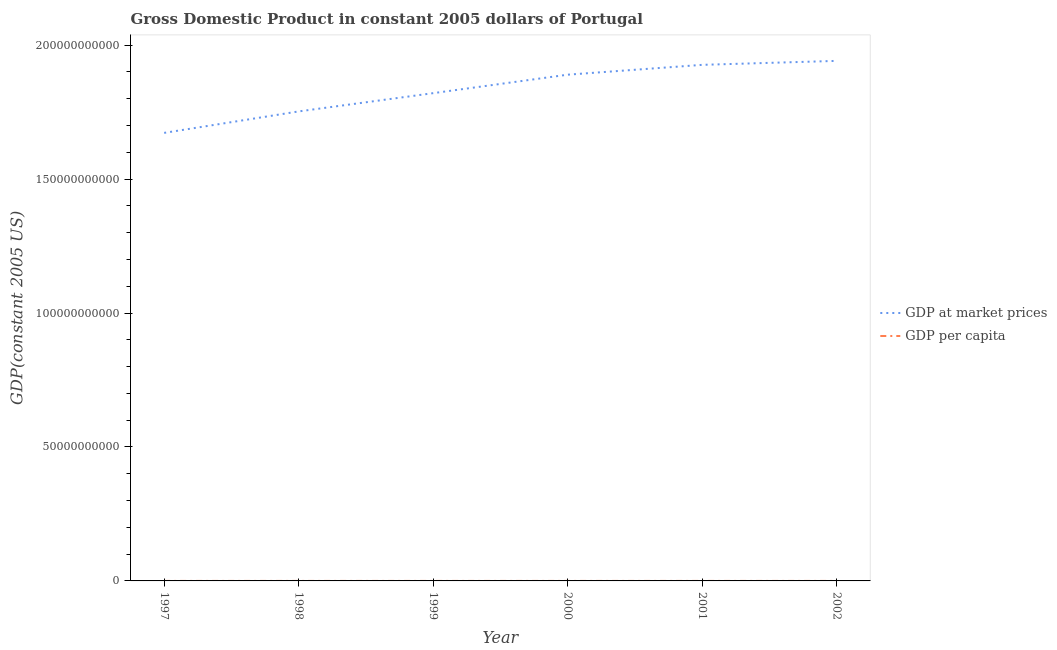What is the gdp per capita in 1998?
Provide a short and direct response. 1.73e+04. Across all years, what is the maximum gdp at market prices?
Provide a short and direct response. 1.94e+11. Across all years, what is the minimum gdp per capita?
Keep it short and to the point. 1.65e+04. In which year was the gdp per capita minimum?
Make the answer very short. 1997. What is the total gdp at market prices in the graph?
Provide a short and direct response. 1.10e+12. What is the difference between the gdp at market prices in 1997 and that in 2001?
Offer a very short reply. -2.54e+1. What is the difference between the gdp per capita in 1997 and the gdp at market prices in 2000?
Ensure brevity in your answer.  -1.89e+11. What is the average gdp at market prices per year?
Your answer should be compact. 1.83e+11. In the year 1998, what is the difference between the gdp at market prices and gdp per capita?
Ensure brevity in your answer.  1.75e+11. What is the ratio of the gdp at market prices in 1998 to that in 2002?
Provide a succinct answer. 0.9. What is the difference between the highest and the second highest gdp at market prices?
Offer a very short reply. 1.48e+09. What is the difference between the highest and the lowest gdp per capita?
Offer a very short reply. 2086.38. In how many years, is the gdp per capita greater than the average gdp per capita taken over all years?
Provide a short and direct response. 3. How many lines are there?
Make the answer very short. 2. Are the values on the major ticks of Y-axis written in scientific E-notation?
Provide a short and direct response. No. How many legend labels are there?
Your response must be concise. 2. How are the legend labels stacked?
Your response must be concise. Vertical. What is the title of the graph?
Provide a short and direct response. Gross Domestic Product in constant 2005 dollars of Portugal. What is the label or title of the Y-axis?
Your answer should be compact. GDP(constant 2005 US). What is the GDP(constant 2005 US) in GDP at market prices in 1997?
Your answer should be compact. 1.67e+11. What is the GDP(constant 2005 US) of GDP per capita in 1997?
Give a very brief answer. 1.65e+04. What is the GDP(constant 2005 US) in GDP at market prices in 1998?
Offer a terse response. 1.75e+11. What is the GDP(constant 2005 US) of GDP per capita in 1998?
Provide a short and direct response. 1.73e+04. What is the GDP(constant 2005 US) in GDP at market prices in 1999?
Ensure brevity in your answer.  1.82e+11. What is the GDP(constant 2005 US) in GDP per capita in 1999?
Make the answer very short. 1.78e+04. What is the GDP(constant 2005 US) of GDP at market prices in 2000?
Your answer should be very brief. 1.89e+11. What is the GDP(constant 2005 US) of GDP per capita in 2000?
Your answer should be very brief. 1.84e+04. What is the GDP(constant 2005 US) of GDP at market prices in 2001?
Your response must be concise. 1.93e+11. What is the GDP(constant 2005 US) in GDP per capita in 2001?
Provide a short and direct response. 1.86e+04. What is the GDP(constant 2005 US) in GDP at market prices in 2002?
Ensure brevity in your answer.  1.94e+11. What is the GDP(constant 2005 US) in GDP per capita in 2002?
Make the answer very short. 1.86e+04. Across all years, what is the maximum GDP(constant 2005 US) in GDP at market prices?
Your answer should be compact. 1.94e+11. Across all years, what is the maximum GDP(constant 2005 US) of GDP per capita?
Ensure brevity in your answer.  1.86e+04. Across all years, what is the minimum GDP(constant 2005 US) of GDP at market prices?
Keep it short and to the point. 1.67e+11. Across all years, what is the minimum GDP(constant 2005 US) in GDP per capita?
Give a very brief answer. 1.65e+04. What is the total GDP(constant 2005 US) in GDP at market prices in the graph?
Your answer should be compact. 1.10e+12. What is the total GDP(constant 2005 US) of GDP per capita in the graph?
Make the answer very short. 1.07e+05. What is the difference between the GDP(constant 2005 US) of GDP at market prices in 1997 and that in 1998?
Keep it short and to the point. -8.01e+09. What is the difference between the GDP(constant 2005 US) of GDP per capita in 1997 and that in 1998?
Your response must be concise. -705.4. What is the difference between the GDP(constant 2005 US) of GDP at market prices in 1997 and that in 1999?
Give a very brief answer. -1.48e+1. What is the difference between the GDP(constant 2005 US) in GDP per capita in 1997 and that in 1999?
Offer a terse response. -1275.05. What is the difference between the GDP(constant 2005 US) in GDP at market prices in 1997 and that in 2000?
Keep it short and to the point. -2.17e+1. What is the difference between the GDP(constant 2005 US) of GDP per capita in 1997 and that in 2000?
Your response must be concise. -1820.45. What is the difference between the GDP(constant 2005 US) of GDP at market prices in 1997 and that in 2001?
Offer a terse response. -2.54e+1. What is the difference between the GDP(constant 2005 US) in GDP per capita in 1997 and that in 2001?
Your response must be concise. -2045.77. What is the difference between the GDP(constant 2005 US) in GDP at market prices in 1997 and that in 2002?
Provide a short and direct response. -2.69e+1. What is the difference between the GDP(constant 2005 US) in GDP per capita in 1997 and that in 2002?
Your answer should be compact. -2086.38. What is the difference between the GDP(constant 2005 US) of GDP at market prices in 1998 and that in 1999?
Make the answer very short. -6.81e+09. What is the difference between the GDP(constant 2005 US) in GDP per capita in 1998 and that in 1999?
Provide a short and direct response. -569.65. What is the difference between the GDP(constant 2005 US) in GDP at market prices in 1998 and that in 2000?
Make the answer very short. -1.37e+1. What is the difference between the GDP(constant 2005 US) in GDP per capita in 1998 and that in 2000?
Provide a succinct answer. -1115.05. What is the difference between the GDP(constant 2005 US) of GDP at market prices in 1998 and that in 2001?
Your answer should be very brief. -1.74e+1. What is the difference between the GDP(constant 2005 US) in GDP per capita in 1998 and that in 2001?
Provide a short and direct response. -1340.38. What is the difference between the GDP(constant 2005 US) in GDP at market prices in 1998 and that in 2002?
Your answer should be very brief. -1.89e+1. What is the difference between the GDP(constant 2005 US) in GDP per capita in 1998 and that in 2002?
Ensure brevity in your answer.  -1380.98. What is the difference between the GDP(constant 2005 US) of GDP at market prices in 1999 and that in 2000?
Your response must be concise. -6.90e+09. What is the difference between the GDP(constant 2005 US) in GDP per capita in 1999 and that in 2000?
Provide a short and direct response. -545.4. What is the difference between the GDP(constant 2005 US) of GDP at market prices in 1999 and that in 2001?
Keep it short and to the point. -1.06e+1. What is the difference between the GDP(constant 2005 US) in GDP per capita in 1999 and that in 2001?
Your response must be concise. -770.72. What is the difference between the GDP(constant 2005 US) in GDP at market prices in 1999 and that in 2002?
Your response must be concise. -1.20e+1. What is the difference between the GDP(constant 2005 US) of GDP per capita in 1999 and that in 2002?
Your response must be concise. -811.33. What is the difference between the GDP(constant 2005 US) of GDP at market prices in 2000 and that in 2001?
Provide a succinct answer. -3.67e+09. What is the difference between the GDP(constant 2005 US) of GDP per capita in 2000 and that in 2001?
Provide a succinct answer. -225.33. What is the difference between the GDP(constant 2005 US) of GDP at market prices in 2000 and that in 2002?
Give a very brief answer. -5.15e+09. What is the difference between the GDP(constant 2005 US) in GDP per capita in 2000 and that in 2002?
Your answer should be compact. -265.93. What is the difference between the GDP(constant 2005 US) in GDP at market prices in 2001 and that in 2002?
Your answer should be compact. -1.48e+09. What is the difference between the GDP(constant 2005 US) in GDP per capita in 2001 and that in 2002?
Ensure brevity in your answer.  -40.61. What is the difference between the GDP(constant 2005 US) of GDP at market prices in 1997 and the GDP(constant 2005 US) of GDP per capita in 1998?
Your response must be concise. 1.67e+11. What is the difference between the GDP(constant 2005 US) in GDP at market prices in 1997 and the GDP(constant 2005 US) in GDP per capita in 1999?
Give a very brief answer. 1.67e+11. What is the difference between the GDP(constant 2005 US) in GDP at market prices in 1997 and the GDP(constant 2005 US) in GDP per capita in 2000?
Your answer should be compact. 1.67e+11. What is the difference between the GDP(constant 2005 US) in GDP at market prices in 1997 and the GDP(constant 2005 US) in GDP per capita in 2001?
Offer a very short reply. 1.67e+11. What is the difference between the GDP(constant 2005 US) of GDP at market prices in 1997 and the GDP(constant 2005 US) of GDP per capita in 2002?
Offer a very short reply. 1.67e+11. What is the difference between the GDP(constant 2005 US) in GDP at market prices in 1998 and the GDP(constant 2005 US) in GDP per capita in 1999?
Keep it short and to the point. 1.75e+11. What is the difference between the GDP(constant 2005 US) in GDP at market prices in 1998 and the GDP(constant 2005 US) in GDP per capita in 2000?
Provide a short and direct response. 1.75e+11. What is the difference between the GDP(constant 2005 US) of GDP at market prices in 1998 and the GDP(constant 2005 US) of GDP per capita in 2001?
Your response must be concise. 1.75e+11. What is the difference between the GDP(constant 2005 US) of GDP at market prices in 1998 and the GDP(constant 2005 US) of GDP per capita in 2002?
Ensure brevity in your answer.  1.75e+11. What is the difference between the GDP(constant 2005 US) of GDP at market prices in 1999 and the GDP(constant 2005 US) of GDP per capita in 2000?
Make the answer very short. 1.82e+11. What is the difference between the GDP(constant 2005 US) in GDP at market prices in 1999 and the GDP(constant 2005 US) in GDP per capita in 2001?
Your response must be concise. 1.82e+11. What is the difference between the GDP(constant 2005 US) in GDP at market prices in 1999 and the GDP(constant 2005 US) in GDP per capita in 2002?
Provide a short and direct response. 1.82e+11. What is the difference between the GDP(constant 2005 US) of GDP at market prices in 2000 and the GDP(constant 2005 US) of GDP per capita in 2001?
Keep it short and to the point. 1.89e+11. What is the difference between the GDP(constant 2005 US) of GDP at market prices in 2000 and the GDP(constant 2005 US) of GDP per capita in 2002?
Make the answer very short. 1.89e+11. What is the difference between the GDP(constant 2005 US) of GDP at market prices in 2001 and the GDP(constant 2005 US) of GDP per capita in 2002?
Ensure brevity in your answer.  1.93e+11. What is the average GDP(constant 2005 US) of GDP at market prices per year?
Offer a very short reply. 1.83e+11. What is the average GDP(constant 2005 US) of GDP per capita per year?
Ensure brevity in your answer.  1.79e+04. In the year 1997, what is the difference between the GDP(constant 2005 US) of GDP at market prices and GDP(constant 2005 US) of GDP per capita?
Offer a terse response. 1.67e+11. In the year 1998, what is the difference between the GDP(constant 2005 US) in GDP at market prices and GDP(constant 2005 US) in GDP per capita?
Offer a very short reply. 1.75e+11. In the year 1999, what is the difference between the GDP(constant 2005 US) in GDP at market prices and GDP(constant 2005 US) in GDP per capita?
Offer a terse response. 1.82e+11. In the year 2000, what is the difference between the GDP(constant 2005 US) in GDP at market prices and GDP(constant 2005 US) in GDP per capita?
Make the answer very short. 1.89e+11. In the year 2001, what is the difference between the GDP(constant 2005 US) in GDP at market prices and GDP(constant 2005 US) in GDP per capita?
Your answer should be very brief. 1.93e+11. In the year 2002, what is the difference between the GDP(constant 2005 US) of GDP at market prices and GDP(constant 2005 US) of GDP per capita?
Keep it short and to the point. 1.94e+11. What is the ratio of the GDP(constant 2005 US) of GDP at market prices in 1997 to that in 1998?
Provide a succinct answer. 0.95. What is the ratio of the GDP(constant 2005 US) of GDP per capita in 1997 to that in 1998?
Offer a very short reply. 0.96. What is the ratio of the GDP(constant 2005 US) in GDP at market prices in 1997 to that in 1999?
Your answer should be very brief. 0.92. What is the ratio of the GDP(constant 2005 US) in GDP per capita in 1997 to that in 1999?
Provide a short and direct response. 0.93. What is the ratio of the GDP(constant 2005 US) in GDP at market prices in 1997 to that in 2000?
Ensure brevity in your answer.  0.89. What is the ratio of the GDP(constant 2005 US) of GDP per capita in 1997 to that in 2000?
Offer a terse response. 0.9. What is the ratio of the GDP(constant 2005 US) in GDP at market prices in 1997 to that in 2001?
Offer a terse response. 0.87. What is the ratio of the GDP(constant 2005 US) of GDP per capita in 1997 to that in 2001?
Keep it short and to the point. 0.89. What is the ratio of the GDP(constant 2005 US) of GDP at market prices in 1997 to that in 2002?
Give a very brief answer. 0.86. What is the ratio of the GDP(constant 2005 US) in GDP per capita in 1997 to that in 2002?
Offer a very short reply. 0.89. What is the ratio of the GDP(constant 2005 US) of GDP at market prices in 1998 to that in 1999?
Provide a short and direct response. 0.96. What is the ratio of the GDP(constant 2005 US) in GDP per capita in 1998 to that in 1999?
Your answer should be very brief. 0.97. What is the ratio of the GDP(constant 2005 US) of GDP at market prices in 1998 to that in 2000?
Offer a terse response. 0.93. What is the ratio of the GDP(constant 2005 US) of GDP per capita in 1998 to that in 2000?
Provide a succinct answer. 0.94. What is the ratio of the GDP(constant 2005 US) in GDP at market prices in 1998 to that in 2001?
Your answer should be compact. 0.91. What is the ratio of the GDP(constant 2005 US) of GDP per capita in 1998 to that in 2001?
Give a very brief answer. 0.93. What is the ratio of the GDP(constant 2005 US) in GDP at market prices in 1998 to that in 2002?
Ensure brevity in your answer.  0.9. What is the ratio of the GDP(constant 2005 US) in GDP per capita in 1998 to that in 2002?
Keep it short and to the point. 0.93. What is the ratio of the GDP(constant 2005 US) of GDP at market prices in 1999 to that in 2000?
Make the answer very short. 0.96. What is the ratio of the GDP(constant 2005 US) in GDP per capita in 1999 to that in 2000?
Provide a short and direct response. 0.97. What is the ratio of the GDP(constant 2005 US) in GDP at market prices in 1999 to that in 2001?
Your response must be concise. 0.95. What is the ratio of the GDP(constant 2005 US) of GDP per capita in 1999 to that in 2001?
Make the answer very short. 0.96. What is the ratio of the GDP(constant 2005 US) of GDP at market prices in 1999 to that in 2002?
Give a very brief answer. 0.94. What is the ratio of the GDP(constant 2005 US) in GDP per capita in 1999 to that in 2002?
Make the answer very short. 0.96. What is the ratio of the GDP(constant 2005 US) of GDP at market prices in 2000 to that in 2001?
Your response must be concise. 0.98. What is the ratio of the GDP(constant 2005 US) of GDP per capita in 2000 to that in 2001?
Make the answer very short. 0.99. What is the ratio of the GDP(constant 2005 US) of GDP at market prices in 2000 to that in 2002?
Ensure brevity in your answer.  0.97. What is the ratio of the GDP(constant 2005 US) in GDP per capita in 2000 to that in 2002?
Provide a succinct answer. 0.99. What is the ratio of the GDP(constant 2005 US) of GDP at market prices in 2001 to that in 2002?
Keep it short and to the point. 0.99. What is the ratio of the GDP(constant 2005 US) of GDP per capita in 2001 to that in 2002?
Make the answer very short. 1. What is the difference between the highest and the second highest GDP(constant 2005 US) of GDP at market prices?
Provide a short and direct response. 1.48e+09. What is the difference between the highest and the second highest GDP(constant 2005 US) in GDP per capita?
Provide a short and direct response. 40.61. What is the difference between the highest and the lowest GDP(constant 2005 US) in GDP at market prices?
Your answer should be compact. 2.69e+1. What is the difference between the highest and the lowest GDP(constant 2005 US) of GDP per capita?
Offer a terse response. 2086.38. 